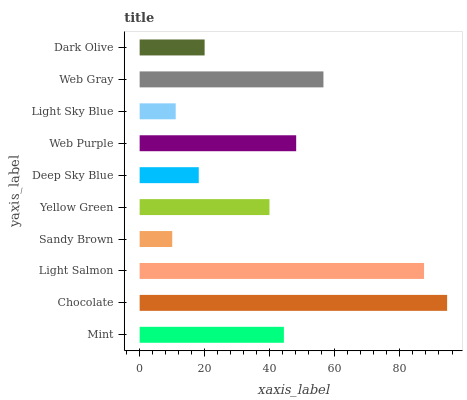Is Sandy Brown the minimum?
Answer yes or no. Yes. Is Chocolate the maximum?
Answer yes or no. Yes. Is Light Salmon the minimum?
Answer yes or no. No. Is Light Salmon the maximum?
Answer yes or no. No. Is Chocolate greater than Light Salmon?
Answer yes or no. Yes. Is Light Salmon less than Chocolate?
Answer yes or no. Yes. Is Light Salmon greater than Chocolate?
Answer yes or no. No. Is Chocolate less than Light Salmon?
Answer yes or no. No. Is Mint the high median?
Answer yes or no. Yes. Is Yellow Green the low median?
Answer yes or no. Yes. Is Chocolate the high median?
Answer yes or no. No. Is Web Gray the low median?
Answer yes or no. No. 